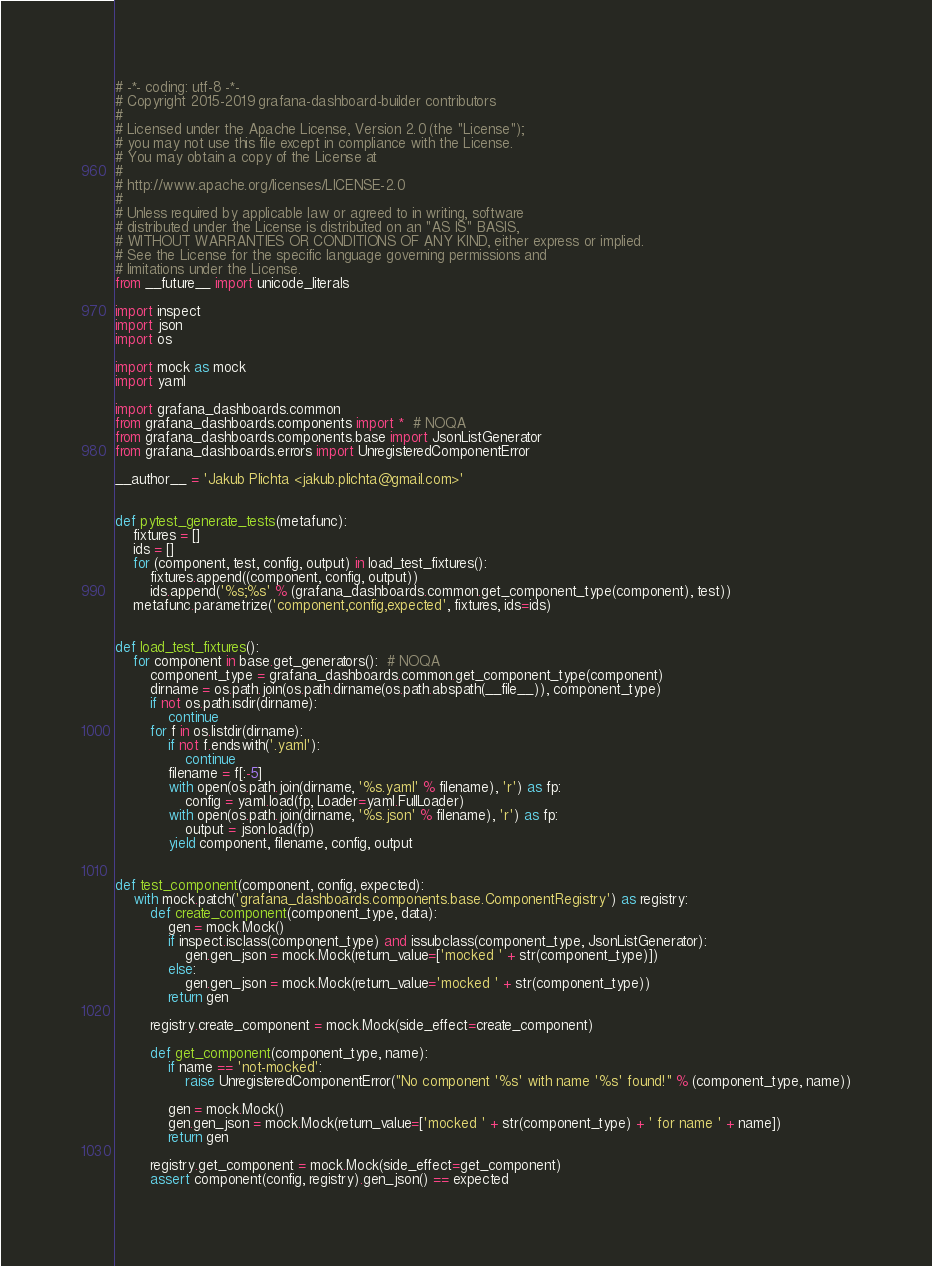Convert code to text. <code><loc_0><loc_0><loc_500><loc_500><_Python_># -*- coding: utf-8 -*-
# Copyright 2015-2019 grafana-dashboard-builder contributors
#
# Licensed under the Apache License, Version 2.0 (the "License");
# you may not use this file except in compliance with the License.
# You may obtain a copy of the License at
#
# http://www.apache.org/licenses/LICENSE-2.0
#
# Unless required by applicable law or agreed to in writing, software
# distributed under the License is distributed on an "AS IS" BASIS,
# WITHOUT WARRANTIES OR CONDITIONS OF ANY KIND, either express or implied.
# See the License for the specific language governing permissions and
# limitations under the License.
from __future__ import unicode_literals

import inspect
import json
import os

import mock as mock
import yaml

import grafana_dashboards.common
from grafana_dashboards.components import *  # NOQA
from grafana_dashboards.components.base import JsonListGenerator
from grafana_dashboards.errors import UnregisteredComponentError

__author__ = 'Jakub Plichta <jakub.plichta@gmail.com>'


def pytest_generate_tests(metafunc):
    fixtures = []
    ids = []
    for (component, test, config, output) in load_test_fixtures():
        fixtures.append((component, config, output))
        ids.append('%s;%s' % (grafana_dashboards.common.get_component_type(component), test))
    metafunc.parametrize('component,config,expected', fixtures, ids=ids)


def load_test_fixtures():
    for component in base.get_generators():  # NOQA
        component_type = grafana_dashboards.common.get_component_type(component)
        dirname = os.path.join(os.path.dirname(os.path.abspath(__file__)), component_type)
        if not os.path.isdir(dirname):
            continue
        for f in os.listdir(dirname):
            if not f.endswith('.yaml'):
                continue
            filename = f[:-5]
            with open(os.path.join(dirname, '%s.yaml' % filename), 'r') as fp:
                config = yaml.load(fp, Loader=yaml.FullLoader)
            with open(os.path.join(dirname, '%s.json' % filename), 'r') as fp:
                output = json.load(fp)
            yield component, filename, config, output


def test_component(component, config, expected):
    with mock.patch('grafana_dashboards.components.base.ComponentRegistry') as registry:
        def create_component(component_type, data):
            gen = mock.Mock()
            if inspect.isclass(component_type) and issubclass(component_type, JsonListGenerator):
                gen.gen_json = mock.Mock(return_value=['mocked ' + str(component_type)])
            else:
                gen.gen_json = mock.Mock(return_value='mocked ' + str(component_type))
            return gen

        registry.create_component = mock.Mock(side_effect=create_component)

        def get_component(component_type, name):
            if name == 'not-mocked':
                raise UnregisteredComponentError("No component '%s' with name '%s' found!" % (component_type, name))

            gen = mock.Mock()
            gen.gen_json = mock.Mock(return_value=['mocked ' + str(component_type) + ' for name ' + name])
            return gen

        registry.get_component = mock.Mock(side_effect=get_component)
        assert component(config, registry).gen_json() == expected
</code> 